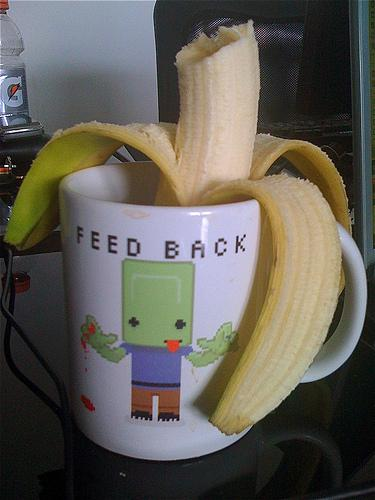Use a narrative tone to portray the situation presented in the image. Upon a black desk, a white coffee mug found a new purpose – to hold a peeled, bitten banana – as the green monster printed on it observed intently. Describe the scene in the image using simple language. There is a cup with a green monster on it and a banana inside it. The cup also has the words "Feed Back" written. Please depict the primary focus of the image and its state. A peeled and bitten yellow banana residing inside a white coffee mug with "Feed Back" written and a green monster on it. Employ creative language while providing a description of the image. A mischievous green monster graces a white mug, housing a tantalizing, half-devoured banana within its porcelain embrace. Mention the objects present in the image and their interaction with each other. A coffee mug containing a peeled banana, featuring a green monster, and words "Feed Back" written on it, rests on a counter with a reflection. Summarize the picture's main elements in a single sentence. A peeled, bitten banana sits in a white mug adorned with a green monster and the words "Feed Back." Imagine you are describing the image to someone who cannot see it. What would you say? Picture a white coffee mug with a green monster drawn on it, the words "Feed Back" written below it, and a peeled, bitten banana resting inside it. Provide a description of the image that focuses on the overall theme and visual elements. The image showcases a white coffee mug, decorated with a quirky green monster and the words "Feed Back," serving as a receptacle for a partially-eaten banana. Focusing on the objects in the image, provide a description highlighting the key elements. A white mug featuring a playful green monster and the phrase "Feed Back" contains a partially-eaten, peeled banana. Explain the primary object in the image and give a brief description of its surroundings. A white coffee mug with a green monster and the text "Feed Back" holds a banana, placed on a counter with a black chair and an empty Gatorade bottle nearby. 